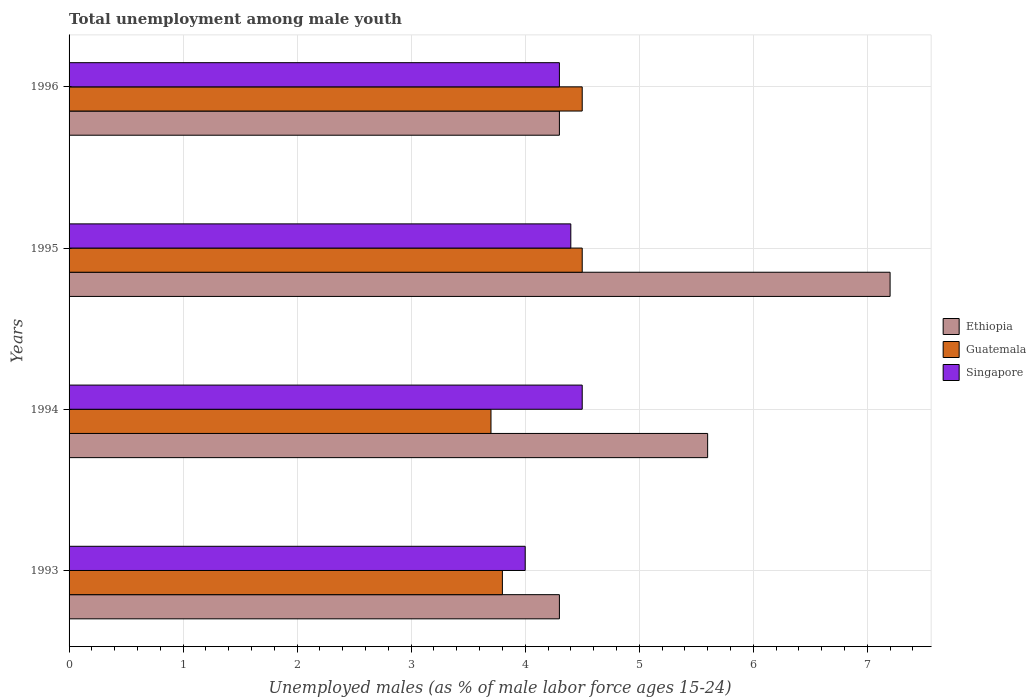How many different coloured bars are there?
Offer a terse response. 3. Are the number of bars on each tick of the Y-axis equal?
Your response must be concise. Yes. How many bars are there on the 3rd tick from the top?
Your answer should be compact. 3. In how many cases, is the number of bars for a given year not equal to the number of legend labels?
Ensure brevity in your answer.  0. Across all years, what is the minimum percentage of unemployed males in in Ethiopia?
Offer a terse response. 4.3. What is the total percentage of unemployed males in in Ethiopia in the graph?
Your response must be concise. 21.4. What is the difference between the percentage of unemployed males in in Singapore in 1995 and that in 1996?
Provide a short and direct response. 0.1. What is the difference between the percentage of unemployed males in in Ethiopia in 1994 and the percentage of unemployed males in in Singapore in 1996?
Offer a terse response. 1.3. What is the average percentage of unemployed males in in Guatemala per year?
Give a very brief answer. 4.12. In the year 1994, what is the difference between the percentage of unemployed males in in Guatemala and percentage of unemployed males in in Singapore?
Keep it short and to the point. -0.8. In how many years, is the percentage of unemployed males in in Ethiopia greater than 5.8 %?
Ensure brevity in your answer.  1. What is the ratio of the percentage of unemployed males in in Guatemala in 1993 to that in 1994?
Give a very brief answer. 1.03. Is the difference between the percentage of unemployed males in in Guatemala in 1994 and 1996 greater than the difference between the percentage of unemployed males in in Singapore in 1994 and 1996?
Your answer should be compact. No. What is the difference between the highest and the second highest percentage of unemployed males in in Singapore?
Provide a short and direct response. 0.1. In how many years, is the percentage of unemployed males in in Guatemala greater than the average percentage of unemployed males in in Guatemala taken over all years?
Keep it short and to the point. 2. What does the 2nd bar from the top in 1993 represents?
Provide a succinct answer. Guatemala. What does the 3rd bar from the bottom in 1993 represents?
Give a very brief answer. Singapore. Is it the case that in every year, the sum of the percentage of unemployed males in in Singapore and percentage of unemployed males in in Ethiopia is greater than the percentage of unemployed males in in Guatemala?
Offer a terse response. Yes. Are all the bars in the graph horizontal?
Make the answer very short. Yes. How many years are there in the graph?
Your response must be concise. 4. Are the values on the major ticks of X-axis written in scientific E-notation?
Ensure brevity in your answer.  No. Where does the legend appear in the graph?
Make the answer very short. Center right. How many legend labels are there?
Provide a succinct answer. 3. How are the legend labels stacked?
Your answer should be very brief. Vertical. What is the title of the graph?
Offer a terse response. Total unemployment among male youth. What is the label or title of the X-axis?
Offer a terse response. Unemployed males (as % of male labor force ages 15-24). What is the Unemployed males (as % of male labor force ages 15-24) of Ethiopia in 1993?
Keep it short and to the point. 4.3. What is the Unemployed males (as % of male labor force ages 15-24) in Guatemala in 1993?
Offer a terse response. 3.8. What is the Unemployed males (as % of male labor force ages 15-24) of Ethiopia in 1994?
Provide a short and direct response. 5.6. What is the Unemployed males (as % of male labor force ages 15-24) of Guatemala in 1994?
Ensure brevity in your answer.  3.7. What is the Unemployed males (as % of male labor force ages 15-24) in Ethiopia in 1995?
Your answer should be compact. 7.2. What is the Unemployed males (as % of male labor force ages 15-24) in Singapore in 1995?
Provide a short and direct response. 4.4. What is the Unemployed males (as % of male labor force ages 15-24) in Ethiopia in 1996?
Your answer should be very brief. 4.3. What is the Unemployed males (as % of male labor force ages 15-24) in Singapore in 1996?
Provide a short and direct response. 4.3. Across all years, what is the maximum Unemployed males (as % of male labor force ages 15-24) of Ethiopia?
Your response must be concise. 7.2. Across all years, what is the minimum Unemployed males (as % of male labor force ages 15-24) in Ethiopia?
Provide a succinct answer. 4.3. Across all years, what is the minimum Unemployed males (as % of male labor force ages 15-24) of Guatemala?
Make the answer very short. 3.7. What is the total Unemployed males (as % of male labor force ages 15-24) of Ethiopia in the graph?
Your answer should be compact. 21.4. What is the total Unemployed males (as % of male labor force ages 15-24) in Guatemala in the graph?
Your answer should be very brief. 16.5. What is the total Unemployed males (as % of male labor force ages 15-24) in Singapore in the graph?
Keep it short and to the point. 17.2. What is the difference between the Unemployed males (as % of male labor force ages 15-24) of Ethiopia in 1993 and that in 1994?
Give a very brief answer. -1.3. What is the difference between the Unemployed males (as % of male labor force ages 15-24) in Guatemala in 1993 and that in 1994?
Your answer should be compact. 0.1. What is the difference between the Unemployed males (as % of male labor force ages 15-24) in Singapore in 1993 and that in 1994?
Make the answer very short. -0.5. What is the difference between the Unemployed males (as % of male labor force ages 15-24) in Ethiopia in 1993 and that in 1995?
Make the answer very short. -2.9. What is the difference between the Unemployed males (as % of male labor force ages 15-24) of Guatemala in 1993 and that in 1995?
Offer a very short reply. -0.7. What is the difference between the Unemployed males (as % of male labor force ages 15-24) of Ethiopia in 1993 and that in 1996?
Ensure brevity in your answer.  0. What is the difference between the Unemployed males (as % of male labor force ages 15-24) in Singapore in 1993 and that in 1996?
Ensure brevity in your answer.  -0.3. What is the difference between the Unemployed males (as % of male labor force ages 15-24) in Ethiopia in 1994 and that in 1996?
Offer a very short reply. 1.3. What is the difference between the Unemployed males (as % of male labor force ages 15-24) in Guatemala in 1994 and that in 1996?
Provide a short and direct response. -0.8. What is the difference between the Unemployed males (as % of male labor force ages 15-24) of Ethiopia in 1995 and that in 1996?
Make the answer very short. 2.9. What is the difference between the Unemployed males (as % of male labor force ages 15-24) in Guatemala in 1995 and that in 1996?
Provide a succinct answer. 0. What is the difference between the Unemployed males (as % of male labor force ages 15-24) in Ethiopia in 1993 and the Unemployed males (as % of male labor force ages 15-24) in Guatemala in 1994?
Provide a succinct answer. 0.6. What is the difference between the Unemployed males (as % of male labor force ages 15-24) in Ethiopia in 1993 and the Unemployed males (as % of male labor force ages 15-24) in Guatemala in 1995?
Keep it short and to the point. -0.2. What is the difference between the Unemployed males (as % of male labor force ages 15-24) in Ethiopia in 1993 and the Unemployed males (as % of male labor force ages 15-24) in Singapore in 1995?
Ensure brevity in your answer.  -0.1. What is the difference between the Unemployed males (as % of male labor force ages 15-24) in Guatemala in 1993 and the Unemployed males (as % of male labor force ages 15-24) in Singapore in 1995?
Your answer should be very brief. -0.6. What is the difference between the Unemployed males (as % of male labor force ages 15-24) in Ethiopia in 1993 and the Unemployed males (as % of male labor force ages 15-24) in Guatemala in 1996?
Your answer should be very brief. -0.2. What is the difference between the Unemployed males (as % of male labor force ages 15-24) of Ethiopia in 1994 and the Unemployed males (as % of male labor force ages 15-24) of Guatemala in 1996?
Ensure brevity in your answer.  1.1. What is the difference between the Unemployed males (as % of male labor force ages 15-24) in Ethiopia in 1994 and the Unemployed males (as % of male labor force ages 15-24) in Singapore in 1996?
Your answer should be very brief. 1.3. What is the difference between the Unemployed males (as % of male labor force ages 15-24) in Guatemala in 1994 and the Unemployed males (as % of male labor force ages 15-24) in Singapore in 1996?
Offer a very short reply. -0.6. What is the difference between the Unemployed males (as % of male labor force ages 15-24) of Ethiopia in 1995 and the Unemployed males (as % of male labor force ages 15-24) of Singapore in 1996?
Your response must be concise. 2.9. What is the average Unemployed males (as % of male labor force ages 15-24) of Ethiopia per year?
Your answer should be compact. 5.35. What is the average Unemployed males (as % of male labor force ages 15-24) in Guatemala per year?
Your answer should be very brief. 4.12. What is the average Unemployed males (as % of male labor force ages 15-24) of Singapore per year?
Your response must be concise. 4.3. In the year 1993, what is the difference between the Unemployed males (as % of male labor force ages 15-24) in Ethiopia and Unemployed males (as % of male labor force ages 15-24) in Singapore?
Your answer should be compact. 0.3. In the year 1993, what is the difference between the Unemployed males (as % of male labor force ages 15-24) in Guatemala and Unemployed males (as % of male labor force ages 15-24) in Singapore?
Offer a very short reply. -0.2. In the year 1994, what is the difference between the Unemployed males (as % of male labor force ages 15-24) in Guatemala and Unemployed males (as % of male labor force ages 15-24) in Singapore?
Provide a short and direct response. -0.8. In the year 1995, what is the difference between the Unemployed males (as % of male labor force ages 15-24) in Ethiopia and Unemployed males (as % of male labor force ages 15-24) in Guatemala?
Keep it short and to the point. 2.7. In the year 1996, what is the difference between the Unemployed males (as % of male labor force ages 15-24) in Ethiopia and Unemployed males (as % of male labor force ages 15-24) in Guatemala?
Ensure brevity in your answer.  -0.2. What is the ratio of the Unemployed males (as % of male labor force ages 15-24) of Ethiopia in 1993 to that in 1994?
Provide a short and direct response. 0.77. What is the ratio of the Unemployed males (as % of male labor force ages 15-24) in Guatemala in 1993 to that in 1994?
Offer a terse response. 1.03. What is the ratio of the Unemployed males (as % of male labor force ages 15-24) in Singapore in 1993 to that in 1994?
Make the answer very short. 0.89. What is the ratio of the Unemployed males (as % of male labor force ages 15-24) in Ethiopia in 1993 to that in 1995?
Give a very brief answer. 0.6. What is the ratio of the Unemployed males (as % of male labor force ages 15-24) in Guatemala in 1993 to that in 1995?
Provide a short and direct response. 0.84. What is the ratio of the Unemployed males (as % of male labor force ages 15-24) in Guatemala in 1993 to that in 1996?
Your answer should be very brief. 0.84. What is the ratio of the Unemployed males (as % of male labor force ages 15-24) of Singapore in 1993 to that in 1996?
Your answer should be compact. 0.93. What is the ratio of the Unemployed males (as % of male labor force ages 15-24) of Guatemala in 1994 to that in 1995?
Make the answer very short. 0.82. What is the ratio of the Unemployed males (as % of male labor force ages 15-24) of Singapore in 1994 to that in 1995?
Provide a succinct answer. 1.02. What is the ratio of the Unemployed males (as % of male labor force ages 15-24) of Ethiopia in 1994 to that in 1996?
Provide a succinct answer. 1.3. What is the ratio of the Unemployed males (as % of male labor force ages 15-24) of Guatemala in 1994 to that in 1996?
Give a very brief answer. 0.82. What is the ratio of the Unemployed males (as % of male labor force ages 15-24) of Singapore in 1994 to that in 1996?
Offer a very short reply. 1.05. What is the ratio of the Unemployed males (as % of male labor force ages 15-24) of Ethiopia in 1995 to that in 1996?
Provide a short and direct response. 1.67. What is the ratio of the Unemployed males (as % of male labor force ages 15-24) of Singapore in 1995 to that in 1996?
Give a very brief answer. 1.02. What is the difference between the highest and the second highest Unemployed males (as % of male labor force ages 15-24) in Ethiopia?
Your answer should be compact. 1.6. What is the difference between the highest and the second highest Unemployed males (as % of male labor force ages 15-24) in Guatemala?
Provide a succinct answer. 0. What is the difference between the highest and the lowest Unemployed males (as % of male labor force ages 15-24) in Ethiopia?
Offer a very short reply. 2.9. 